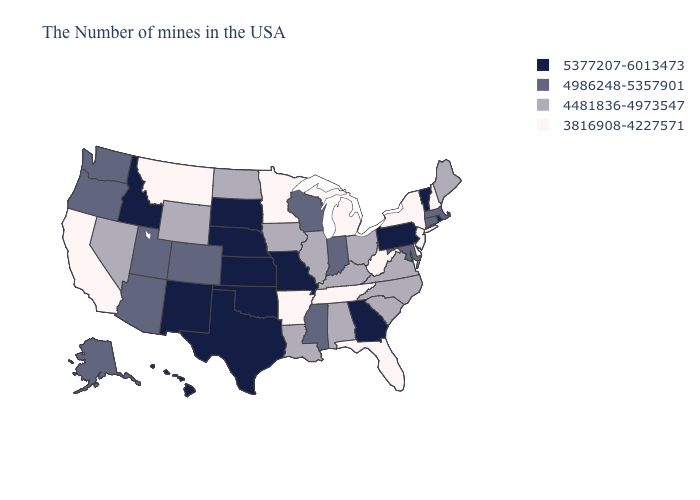Does Wisconsin have the lowest value in the USA?
Concise answer only. No. Name the states that have a value in the range 4481836-4973547?
Short answer required. Maine, Virginia, North Carolina, South Carolina, Ohio, Kentucky, Alabama, Illinois, Louisiana, Iowa, North Dakota, Wyoming, Nevada. Name the states that have a value in the range 5377207-6013473?
Quick response, please. Rhode Island, Vermont, Pennsylvania, Georgia, Missouri, Kansas, Nebraska, Oklahoma, Texas, South Dakota, New Mexico, Idaho, Hawaii. Name the states that have a value in the range 3816908-4227571?
Write a very short answer. New Hampshire, New York, New Jersey, Delaware, West Virginia, Florida, Michigan, Tennessee, Arkansas, Minnesota, Montana, California. Does the map have missing data?
Keep it brief. No. Name the states that have a value in the range 5377207-6013473?
Write a very short answer. Rhode Island, Vermont, Pennsylvania, Georgia, Missouri, Kansas, Nebraska, Oklahoma, Texas, South Dakota, New Mexico, Idaho, Hawaii. Which states have the lowest value in the USA?
Short answer required. New Hampshire, New York, New Jersey, Delaware, West Virginia, Florida, Michigan, Tennessee, Arkansas, Minnesota, Montana, California. Name the states that have a value in the range 4481836-4973547?
Keep it brief. Maine, Virginia, North Carolina, South Carolina, Ohio, Kentucky, Alabama, Illinois, Louisiana, Iowa, North Dakota, Wyoming, Nevada. Name the states that have a value in the range 3816908-4227571?
Answer briefly. New Hampshire, New York, New Jersey, Delaware, West Virginia, Florida, Michigan, Tennessee, Arkansas, Minnesota, Montana, California. Which states have the lowest value in the MidWest?
Be succinct. Michigan, Minnesota. What is the value of Kentucky?
Quick response, please. 4481836-4973547. Among the states that border Tennessee , which have the lowest value?
Short answer required. Arkansas. Which states have the highest value in the USA?
Answer briefly. Rhode Island, Vermont, Pennsylvania, Georgia, Missouri, Kansas, Nebraska, Oklahoma, Texas, South Dakota, New Mexico, Idaho, Hawaii. Name the states that have a value in the range 5377207-6013473?
Write a very short answer. Rhode Island, Vermont, Pennsylvania, Georgia, Missouri, Kansas, Nebraska, Oklahoma, Texas, South Dakota, New Mexico, Idaho, Hawaii. Among the states that border Rhode Island , which have the highest value?
Be succinct. Massachusetts, Connecticut. 